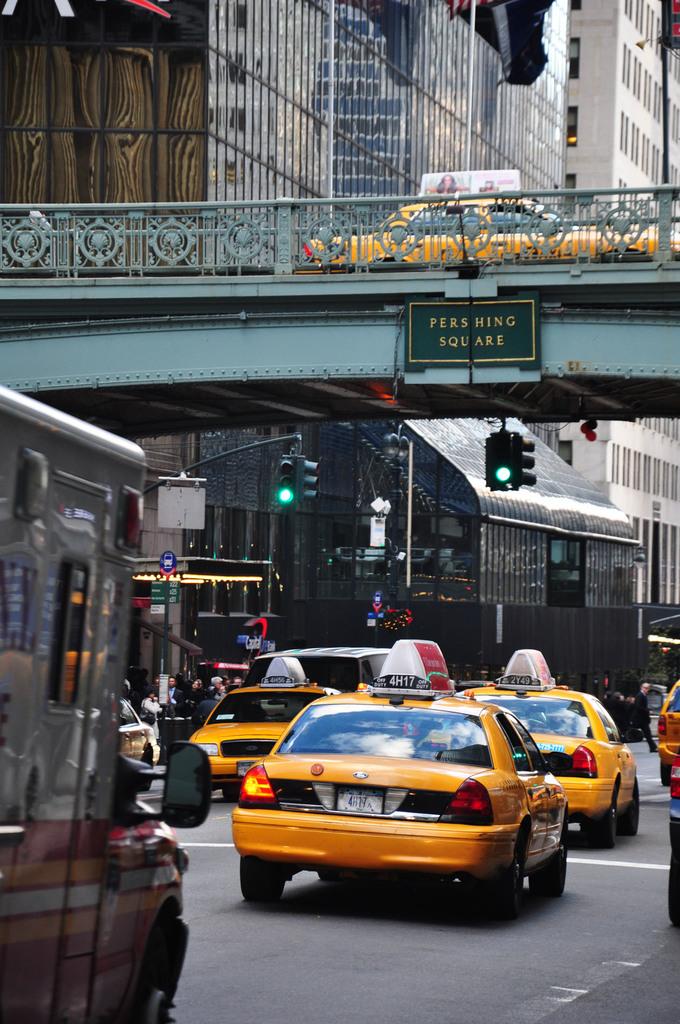What square are they passing by?
Provide a succinct answer. Pershing. 